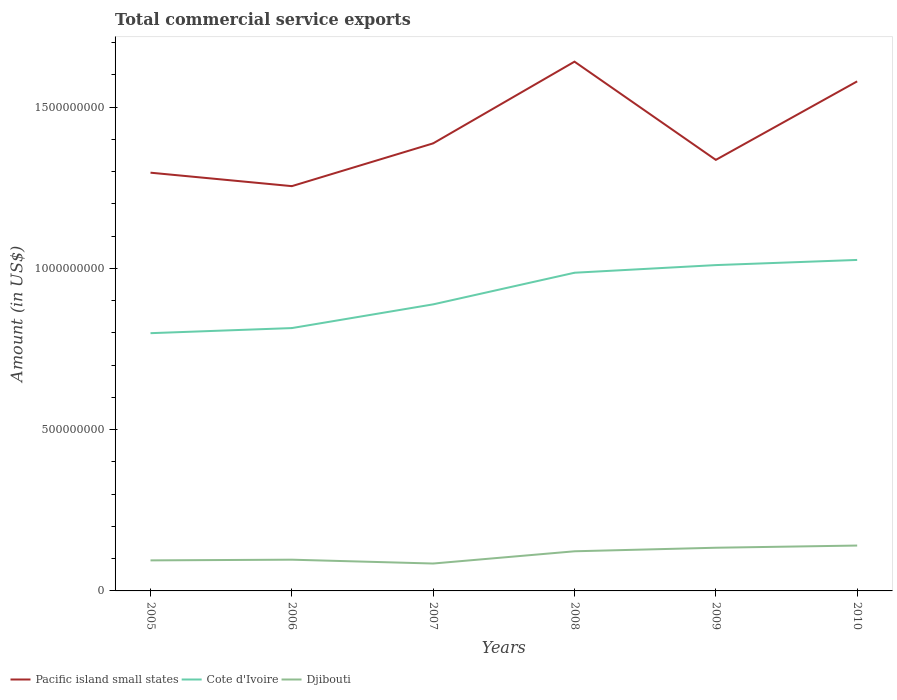How many different coloured lines are there?
Your answer should be compact. 3. Does the line corresponding to Cote d'Ivoire intersect with the line corresponding to Pacific island small states?
Make the answer very short. No. Across all years, what is the maximum total commercial service exports in Djibouti?
Provide a succinct answer. 8.50e+07. What is the total total commercial service exports in Djibouti in the graph?
Provide a short and direct response. -4.90e+07. What is the difference between the highest and the second highest total commercial service exports in Pacific island small states?
Provide a short and direct response. 3.86e+08. Is the total commercial service exports in Cote d'Ivoire strictly greater than the total commercial service exports in Pacific island small states over the years?
Ensure brevity in your answer.  Yes. How many years are there in the graph?
Offer a very short reply. 6. Are the values on the major ticks of Y-axis written in scientific E-notation?
Your answer should be very brief. No. Where does the legend appear in the graph?
Give a very brief answer. Bottom left. What is the title of the graph?
Ensure brevity in your answer.  Total commercial service exports. What is the label or title of the X-axis?
Keep it short and to the point. Years. What is the label or title of the Y-axis?
Your answer should be compact. Amount (in US$). What is the Amount (in US$) in Pacific island small states in 2005?
Offer a very short reply. 1.30e+09. What is the Amount (in US$) in Cote d'Ivoire in 2005?
Ensure brevity in your answer.  7.99e+08. What is the Amount (in US$) in Djibouti in 2005?
Keep it short and to the point. 9.47e+07. What is the Amount (in US$) of Pacific island small states in 2006?
Make the answer very short. 1.26e+09. What is the Amount (in US$) in Cote d'Ivoire in 2006?
Ensure brevity in your answer.  8.15e+08. What is the Amount (in US$) of Djibouti in 2006?
Ensure brevity in your answer.  9.68e+07. What is the Amount (in US$) in Pacific island small states in 2007?
Your response must be concise. 1.39e+09. What is the Amount (in US$) in Cote d'Ivoire in 2007?
Make the answer very short. 8.89e+08. What is the Amount (in US$) in Djibouti in 2007?
Offer a terse response. 8.50e+07. What is the Amount (in US$) in Pacific island small states in 2008?
Provide a succinct answer. 1.64e+09. What is the Amount (in US$) of Cote d'Ivoire in 2008?
Offer a terse response. 9.87e+08. What is the Amount (in US$) of Djibouti in 2008?
Your answer should be compact. 1.23e+08. What is the Amount (in US$) of Pacific island small states in 2009?
Your answer should be very brief. 1.34e+09. What is the Amount (in US$) in Cote d'Ivoire in 2009?
Provide a succinct answer. 1.01e+09. What is the Amount (in US$) of Djibouti in 2009?
Provide a short and direct response. 1.34e+08. What is the Amount (in US$) of Pacific island small states in 2010?
Offer a terse response. 1.58e+09. What is the Amount (in US$) in Cote d'Ivoire in 2010?
Ensure brevity in your answer.  1.03e+09. What is the Amount (in US$) of Djibouti in 2010?
Provide a succinct answer. 1.41e+08. Across all years, what is the maximum Amount (in US$) in Pacific island small states?
Give a very brief answer. 1.64e+09. Across all years, what is the maximum Amount (in US$) in Cote d'Ivoire?
Give a very brief answer. 1.03e+09. Across all years, what is the maximum Amount (in US$) of Djibouti?
Offer a terse response. 1.41e+08. Across all years, what is the minimum Amount (in US$) in Pacific island small states?
Provide a succinct answer. 1.26e+09. Across all years, what is the minimum Amount (in US$) of Cote d'Ivoire?
Your answer should be compact. 7.99e+08. Across all years, what is the minimum Amount (in US$) in Djibouti?
Give a very brief answer. 8.50e+07. What is the total Amount (in US$) in Pacific island small states in the graph?
Provide a succinct answer. 8.50e+09. What is the total Amount (in US$) of Cote d'Ivoire in the graph?
Your response must be concise. 5.53e+09. What is the total Amount (in US$) in Djibouti in the graph?
Keep it short and to the point. 6.74e+08. What is the difference between the Amount (in US$) of Pacific island small states in 2005 and that in 2006?
Ensure brevity in your answer.  4.17e+07. What is the difference between the Amount (in US$) of Cote d'Ivoire in 2005 and that in 2006?
Ensure brevity in your answer.  -1.58e+07. What is the difference between the Amount (in US$) of Djibouti in 2005 and that in 2006?
Your answer should be compact. -2.09e+06. What is the difference between the Amount (in US$) in Pacific island small states in 2005 and that in 2007?
Give a very brief answer. -9.10e+07. What is the difference between the Amount (in US$) of Cote d'Ivoire in 2005 and that in 2007?
Keep it short and to the point. -8.93e+07. What is the difference between the Amount (in US$) of Djibouti in 2005 and that in 2007?
Offer a very short reply. 9.78e+06. What is the difference between the Amount (in US$) in Pacific island small states in 2005 and that in 2008?
Your answer should be compact. -3.44e+08. What is the difference between the Amount (in US$) of Cote d'Ivoire in 2005 and that in 2008?
Provide a succinct answer. -1.87e+08. What is the difference between the Amount (in US$) of Djibouti in 2005 and that in 2008?
Provide a short and direct response. -2.82e+07. What is the difference between the Amount (in US$) in Pacific island small states in 2005 and that in 2009?
Your response must be concise. -3.97e+07. What is the difference between the Amount (in US$) in Cote d'Ivoire in 2005 and that in 2009?
Provide a short and direct response. -2.11e+08. What is the difference between the Amount (in US$) in Djibouti in 2005 and that in 2009?
Provide a short and direct response. -3.92e+07. What is the difference between the Amount (in US$) in Pacific island small states in 2005 and that in 2010?
Offer a terse response. -2.83e+08. What is the difference between the Amount (in US$) in Cote d'Ivoire in 2005 and that in 2010?
Offer a terse response. -2.27e+08. What is the difference between the Amount (in US$) in Djibouti in 2005 and that in 2010?
Keep it short and to the point. -4.59e+07. What is the difference between the Amount (in US$) in Pacific island small states in 2006 and that in 2007?
Offer a terse response. -1.33e+08. What is the difference between the Amount (in US$) in Cote d'Ivoire in 2006 and that in 2007?
Keep it short and to the point. -7.35e+07. What is the difference between the Amount (in US$) in Djibouti in 2006 and that in 2007?
Provide a succinct answer. 1.19e+07. What is the difference between the Amount (in US$) in Pacific island small states in 2006 and that in 2008?
Your response must be concise. -3.86e+08. What is the difference between the Amount (in US$) in Cote d'Ivoire in 2006 and that in 2008?
Provide a succinct answer. -1.72e+08. What is the difference between the Amount (in US$) of Djibouti in 2006 and that in 2008?
Your response must be concise. -2.61e+07. What is the difference between the Amount (in US$) in Pacific island small states in 2006 and that in 2009?
Your answer should be compact. -8.14e+07. What is the difference between the Amount (in US$) of Cote d'Ivoire in 2006 and that in 2009?
Make the answer very short. -1.95e+08. What is the difference between the Amount (in US$) of Djibouti in 2006 and that in 2009?
Your response must be concise. -3.71e+07. What is the difference between the Amount (in US$) of Pacific island small states in 2006 and that in 2010?
Provide a short and direct response. -3.25e+08. What is the difference between the Amount (in US$) in Cote d'Ivoire in 2006 and that in 2010?
Offer a very short reply. -2.11e+08. What is the difference between the Amount (in US$) in Djibouti in 2006 and that in 2010?
Offer a very short reply. -4.39e+07. What is the difference between the Amount (in US$) of Pacific island small states in 2007 and that in 2008?
Your response must be concise. -2.53e+08. What is the difference between the Amount (in US$) in Cote d'Ivoire in 2007 and that in 2008?
Provide a short and direct response. -9.81e+07. What is the difference between the Amount (in US$) in Djibouti in 2007 and that in 2008?
Give a very brief answer. -3.79e+07. What is the difference between the Amount (in US$) of Pacific island small states in 2007 and that in 2009?
Provide a short and direct response. 5.12e+07. What is the difference between the Amount (in US$) in Cote d'Ivoire in 2007 and that in 2009?
Offer a terse response. -1.22e+08. What is the difference between the Amount (in US$) in Djibouti in 2007 and that in 2009?
Give a very brief answer. -4.90e+07. What is the difference between the Amount (in US$) in Pacific island small states in 2007 and that in 2010?
Offer a very short reply. -1.92e+08. What is the difference between the Amount (in US$) in Cote d'Ivoire in 2007 and that in 2010?
Your answer should be compact. -1.38e+08. What is the difference between the Amount (in US$) of Djibouti in 2007 and that in 2010?
Offer a terse response. -5.57e+07. What is the difference between the Amount (in US$) in Pacific island small states in 2008 and that in 2009?
Keep it short and to the point. 3.05e+08. What is the difference between the Amount (in US$) in Cote d'Ivoire in 2008 and that in 2009?
Offer a terse response. -2.37e+07. What is the difference between the Amount (in US$) in Djibouti in 2008 and that in 2009?
Provide a short and direct response. -1.10e+07. What is the difference between the Amount (in US$) of Pacific island small states in 2008 and that in 2010?
Offer a very short reply. 6.11e+07. What is the difference between the Amount (in US$) in Cote d'Ivoire in 2008 and that in 2010?
Ensure brevity in your answer.  -3.97e+07. What is the difference between the Amount (in US$) of Djibouti in 2008 and that in 2010?
Offer a very short reply. -1.78e+07. What is the difference between the Amount (in US$) of Pacific island small states in 2009 and that in 2010?
Your answer should be very brief. -2.43e+08. What is the difference between the Amount (in US$) in Cote d'Ivoire in 2009 and that in 2010?
Offer a very short reply. -1.60e+07. What is the difference between the Amount (in US$) of Djibouti in 2009 and that in 2010?
Offer a terse response. -6.77e+06. What is the difference between the Amount (in US$) of Pacific island small states in 2005 and the Amount (in US$) of Cote d'Ivoire in 2006?
Provide a short and direct response. 4.82e+08. What is the difference between the Amount (in US$) of Pacific island small states in 2005 and the Amount (in US$) of Djibouti in 2006?
Provide a succinct answer. 1.20e+09. What is the difference between the Amount (in US$) of Cote d'Ivoire in 2005 and the Amount (in US$) of Djibouti in 2006?
Provide a short and direct response. 7.02e+08. What is the difference between the Amount (in US$) of Pacific island small states in 2005 and the Amount (in US$) of Cote d'Ivoire in 2007?
Ensure brevity in your answer.  4.08e+08. What is the difference between the Amount (in US$) of Pacific island small states in 2005 and the Amount (in US$) of Djibouti in 2007?
Your response must be concise. 1.21e+09. What is the difference between the Amount (in US$) in Cote d'Ivoire in 2005 and the Amount (in US$) in Djibouti in 2007?
Give a very brief answer. 7.14e+08. What is the difference between the Amount (in US$) in Pacific island small states in 2005 and the Amount (in US$) in Cote d'Ivoire in 2008?
Offer a terse response. 3.10e+08. What is the difference between the Amount (in US$) in Pacific island small states in 2005 and the Amount (in US$) in Djibouti in 2008?
Offer a terse response. 1.17e+09. What is the difference between the Amount (in US$) in Cote d'Ivoire in 2005 and the Amount (in US$) in Djibouti in 2008?
Make the answer very short. 6.76e+08. What is the difference between the Amount (in US$) of Pacific island small states in 2005 and the Amount (in US$) of Cote d'Ivoire in 2009?
Give a very brief answer. 2.87e+08. What is the difference between the Amount (in US$) in Pacific island small states in 2005 and the Amount (in US$) in Djibouti in 2009?
Provide a short and direct response. 1.16e+09. What is the difference between the Amount (in US$) in Cote d'Ivoire in 2005 and the Amount (in US$) in Djibouti in 2009?
Your response must be concise. 6.65e+08. What is the difference between the Amount (in US$) of Pacific island small states in 2005 and the Amount (in US$) of Cote d'Ivoire in 2010?
Provide a short and direct response. 2.71e+08. What is the difference between the Amount (in US$) in Pacific island small states in 2005 and the Amount (in US$) in Djibouti in 2010?
Provide a short and direct response. 1.16e+09. What is the difference between the Amount (in US$) in Cote d'Ivoire in 2005 and the Amount (in US$) in Djibouti in 2010?
Your response must be concise. 6.59e+08. What is the difference between the Amount (in US$) of Pacific island small states in 2006 and the Amount (in US$) of Cote d'Ivoire in 2007?
Give a very brief answer. 3.67e+08. What is the difference between the Amount (in US$) of Pacific island small states in 2006 and the Amount (in US$) of Djibouti in 2007?
Your answer should be very brief. 1.17e+09. What is the difference between the Amount (in US$) in Cote d'Ivoire in 2006 and the Amount (in US$) in Djibouti in 2007?
Give a very brief answer. 7.30e+08. What is the difference between the Amount (in US$) of Pacific island small states in 2006 and the Amount (in US$) of Cote d'Ivoire in 2008?
Ensure brevity in your answer.  2.69e+08. What is the difference between the Amount (in US$) of Pacific island small states in 2006 and the Amount (in US$) of Djibouti in 2008?
Provide a short and direct response. 1.13e+09. What is the difference between the Amount (in US$) of Cote d'Ivoire in 2006 and the Amount (in US$) of Djibouti in 2008?
Offer a very short reply. 6.92e+08. What is the difference between the Amount (in US$) in Pacific island small states in 2006 and the Amount (in US$) in Cote d'Ivoire in 2009?
Offer a terse response. 2.45e+08. What is the difference between the Amount (in US$) in Pacific island small states in 2006 and the Amount (in US$) in Djibouti in 2009?
Your answer should be very brief. 1.12e+09. What is the difference between the Amount (in US$) of Cote d'Ivoire in 2006 and the Amount (in US$) of Djibouti in 2009?
Make the answer very short. 6.81e+08. What is the difference between the Amount (in US$) in Pacific island small states in 2006 and the Amount (in US$) in Cote d'Ivoire in 2010?
Give a very brief answer. 2.29e+08. What is the difference between the Amount (in US$) of Pacific island small states in 2006 and the Amount (in US$) of Djibouti in 2010?
Keep it short and to the point. 1.11e+09. What is the difference between the Amount (in US$) in Cote d'Ivoire in 2006 and the Amount (in US$) in Djibouti in 2010?
Provide a short and direct response. 6.74e+08. What is the difference between the Amount (in US$) in Pacific island small states in 2007 and the Amount (in US$) in Cote d'Ivoire in 2008?
Your response must be concise. 4.01e+08. What is the difference between the Amount (in US$) in Pacific island small states in 2007 and the Amount (in US$) in Djibouti in 2008?
Give a very brief answer. 1.26e+09. What is the difference between the Amount (in US$) in Cote d'Ivoire in 2007 and the Amount (in US$) in Djibouti in 2008?
Offer a terse response. 7.66e+08. What is the difference between the Amount (in US$) of Pacific island small states in 2007 and the Amount (in US$) of Cote d'Ivoire in 2009?
Your response must be concise. 3.78e+08. What is the difference between the Amount (in US$) of Pacific island small states in 2007 and the Amount (in US$) of Djibouti in 2009?
Offer a terse response. 1.25e+09. What is the difference between the Amount (in US$) of Cote d'Ivoire in 2007 and the Amount (in US$) of Djibouti in 2009?
Offer a very short reply. 7.55e+08. What is the difference between the Amount (in US$) in Pacific island small states in 2007 and the Amount (in US$) in Cote d'Ivoire in 2010?
Ensure brevity in your answer.  3.61e+08. What is the difference between the Amount (in US$) of Pacific island small states in 2007 and the Amount (in US$) of Djibouti in 2010?
Offer a very short reply. 1.25e+09. What is the difference between the Amount (in US$) in Cote d'Ivoire in 2007 and the Amount (in US$) in Djibouti in 2010?
Your answer should be compact. 7.48e+08. What is the difference between the Amount (in US$) of Pacific island small states in 2008 and the Amount (in US$) of Cote d'Ivoire in 2009?
Provide a succinct answer. 6.31e+08. What is the difference between the Amount (in US$) of Pacific island small states in 2008 and the Amount (in US$) of Djibouti in 2009?
Make the answer very short. 1.51e+09. What is the difference between the Amount (in US$) in Cote d'Ivoire in 2008 and the Amount (in US$) in Djibouti in 2009?
Your answer should be very brief. 8.53e+08. What is the difference between the Amount (in US$) in Pacific island small states in 2008 and the Amount (in US$) in Cote d'Ivoire in 2010?
Your answer should be very brief. 6.15e+08. What is the difference between the Amount (in US$) of Pacific island small states in 2008 and the Amount (in US$) of Djibouti in 2010?
Provide a succinct answer. 1.50e+09. What is the difference between the Amount (in US$) in Cote d'Ivoire in 2008 and the Amount (in US$) in Djibouti in 2010?
Make the answer very short. 8.46e+08. What is the difference between the Amount (in US$) of Pacific island small states in 2009 and the Amount (in US$) of Cote d'Ivoire in 2010?
Provide a short and direct response. 3.10e+08. What is the difference between the Amount (in US$) in Pacific island small states in 2009 and the Amount (in US$) in Djibouti in 2010?
Offer a very short reply. 1.20e+09. What is the difference between the Amount (in US$) of Cote d'Ivoire in 2009 and the Amount (in US$) of Djibouti in 2010?
Give a very brief answer. 8.70e+08. What is the average Amount (in US$) in Pacific island small states per year?
Ensure brevity in your answer.  1.42e+09. What is the average Amount (in US$) of Cote d'Ivoire per year?
Offer a very short reply. 9.21e+08. What is the average Amount (in US$) of Djibouti per year?
Give a very brief answer. 1.12e+08. In the year 2005, what is the difference between the Amount (in US$) of Pacific island small states and Amount (in US$) of Cote d'Ivoire?
Provide a succinct answer. 4.98e+08. In the year 2005, what is the difference between the Amount (in US$) in Pacific island small states and Amount (in US$) in Djibouti?
Provide a short and direct response. 1.20e+09. In the year 2005, what is the difference between the Amount (in US$) in Cote d'Ivoire and Amount (in US$) in Djibouti?
Your answer should be compact. 7.05e+08. In the year 2006, what is the difference between the Amount (in US$) in Pacific island small states and Amount (in US$) in Cote d'Ivoire?
Your answer should be compact. 4.40e+08. In the year 2006, what is the difference between the Amount (in US$) in Pacific island small states and Amount (in US$) in Djibouti?
Provide a succinct answer. 1.16e+09. In the year 2006, what is the difference between the Amount (in US$) in Cote d'Ivoire and Amount (in US$) in Djibouti?
Offer a terse response. 7.18e+08. In the year 2007, what is the difference between the Amount (in US$) of Pacific island small states and Amount (in US$) of Cote d'Ivoire?
Your answer should be compact. 4.99e+08. In the year 2007, what is the difference between the Amount (in US$) in Pacific island small states and Amount (in US$) in Djibouti?
Your answer should be very brief. 1.30e+09. In the year 2007, what is the difference between the Amount (in US$) in Cote d'Ivoire and Amount (in US$) in Djibouti?
Your answer should be very brief. 8.04e+08. In the year 2008, what is the difference between the Amount (in US$) in Pacific island small states and Amount (in US$) in Cote d'Ivoire?
Offer a terse response. 6.55e+08. In the year 2008, what is the difference between the Amount (in US$) in Pacific island small states and Amount (in US$) in Djibouti?
Provide a short and direct response. 1.52e+09. In the year 2008, what is the difference between the Amount (in US$) in Cote d'Ivoire and Amount (in US$) in Djibouti?
Ensure brevity in your answer.  8.64e+08. In the year 2009, what is the difference between the Amount (in US$) of Pacific island small states and Amount (in US$) of Cote d'Ivoire?
Make the answer very short. 3.26e+08. In the year 2009, what is the difference between the Amount (in US$) in Pacific island small states and Amount (in US$) in Djibouti?
Provide a succinct answer. 1.20e+09. In the year 2009, what is the difference between the Amount (in US$) in Cote d'Ivoire and Amount (in US$) in Djibouti?
Keep it short and to the point. 8.76e+08. In the year 2010, what is the difference between the Amount (in US$) of Pacific island small states and Amount (in US$) of Cote d'Ivoire?
Keep it short and to the point. 5.54e+08. In the year 2010, what is the difference between the Amount (in US$) in Pacific island small states and Amount (in US$) in Djibouti?
Your response must be concise. 1.44e+09. In the year 2010, what is the difference between the Amount (in US$) of Cote d'Ivoire and Amount (in US$) of Djibouti?
Make the answer very short. 8.86e+08. What is the ratio of the Amount (in US$) of Pacific island small states in 2005 to that in 2006?
Your response must be concise. 1.03. What is the ratio of the Amount (in US$) in Cote d'Ivoire in 2005 to that in 2006?
Your answer should be very brief. 0.98. What is the ratio of the Amount (in US$) in Djibouti in 2005 to that in 2006?
Your response must be concise. 0.98. What is the ratio of the Amount (in US$) in Pacific island small states in 2005 to that in 2007?
Your answer should be very brief. 0.93. What is the ratio of the Amount (in US$) in Cote d'Ivoire in 2005 to that in 2007?
Offer a very short reply. 0.9. What is the ratio of the Amount (in US$) of Djibouti in 2005 to that in 2007?
Ensure brevity in your answer.  1.12. What is the ratio of the Amount (in US$) of Pacific island small states in 2005 to that in 2008?
Ensure brevity in your answer.  0.79. What is the ratio of the Amount (in US$) of Cote d'Ivoire in 2005 to that in 2008?
Your answer should be very brief. 0.81. What is the ratio of the Amount (in US$) of Djibouti in 2005 to that in 2008?
Provide a short and direct response. 0.77. What is the ratio of the Amount (in US$) in Pacific island small states in 2005 to that in 2009?
Keep it short and to the point. 0.97. What is the ratio of the Amount (in US$) in Cote d'Ivoire in 2005 to that in 2009?
Give a very brief answer. 0.79. What is the ratio of the Amount (in US$) of Djibouti in 2005 to that in 2009?
Your answer should be compact. 0.71. What is the ratio of the Amount (in US$) in Pacific island small states in 2005 to that in 2010?
Ensure brevity in your answer.  0.82. What is the ratio of the Amount (in US$) in Cote d'Ivoire in 2005 to that in 2010?
Your response must be concise. 0.78. What is the ratio of the Amount (in US$) of Djibouti in 2005 to that in 2010?
Your response must be concise. 0.67. What is the ratio of the Amount (in US$) in Pacific island small states in 2006 to that in 2007?
Offer a very short reply. 0.9. What is the ratio of the Amount (in US$) in Cote d'Ivoire in 2006 to that in 2007?
Your answer should be very brief. 0.92. What is the ratio of the Amount (in US$) of Djibouti in 2006 to that in 2007?
Your response must be concise. 1.14. What is the ratio of the Amount (in US$) in Pacific island small states in 2006 to that in 2008?
Offer a very short reply. 0.76. What is the ratio of the Amount (in US$) in Cote d'Ivoire in 2006 to that in 2008?
Your answer should be compact. 0.83. What is the ratio of the Amount (in US$) in Djibouti in 2006 to that in 2008?
Your answer should be compact. 0.79. What is the ratio of the Amount (in US$) of Pacific island small states in 2006 to that in 2009?
Your response must be concise. 0.94. What is the ratio of the Amount (in US$) of Cote d'Ivoire in 2006 to that in 2009?
Offer a very short reply. 0.81. What is the ratio of the Amount (in US$) of Djibouti in 2006 to that in 2009?
Your answer should be compact. 0.72. What is the ratio of the Amount (in US$) in Pacific island small states in 2006 to that in 2010?
Your answer should be compact. 0.79. What is the ratio of the Amount (in US$) of Cote d'Ivoire in 2006 to that in 2010?
Give a very brief answer. 0.79. What is the ratio of the Amount (in US$) of Djibouti in 2006 to that in 2010?
Offer a terse response. 0.69. What is the ratio of the Amount (in US$) of Pacific island small states in 2007 to that in 2008?
Offer a very short reply. 0.85. What is the ratio of the Amount (in US$) in Cote d'Ivoire in 2007 to that in 2008?
Your response must be concise. 0.9. What is the ratio of the Amount (in US$) in Djibouti in 2007 to that in 2008?
Offer a very short reply. 0.69. What is the ratio of the Amount (in US$) in Pacific island small states in 2007 to that in 2009?
Make the answer very short. 1.04. What is the ratio of the Amount (in US$) of Cote d'Ivoire in 2007 to that in 2009?
Your answer should be very brief. 0.88. What is the ratio of the Amount (in US$) of Djibouti in 2007 to that in 2009?
Keep it short and to the point. 0.63. What is the ratio of the Amount (in US$) of Pacific island small states in 2007 to that in 2010?
Provide a short and direct response. 0.88. What is the ratio of the Amount (in US$) in Cote d'Ivoire in 2007 to that in 2010?
Keep it short and to the point. 0.87. What is the ratio of the Amount (in US$) of Djibouti in 2007 to that in 2010?
Your response must be concise. 0.6. What is the ratio of the Amount (in US$) in Pacific island small states in 2008 to that in 2009?
Your answer should be compact. 1.23. What is the ratio of the Amount (in US$) of Cote d'Ivoire in 2008 to that in 2009?
Make the answer very short. 0.98. What is the ratio of the Amount (in US$) of Djibouti in 2008 to that in 2009?
Give a very brief answer. 0.92. What is the ratio of the Amount (in US$) in Pacific island small states in 2008 to that in 2010?
Give a very brief answer. 1.04. What is the ratio of the Amount (in US$) of Cote d'Ivoire in 2008 to that in 2010?
Provide a short and direct response. 0.96. What is the ratio of the Amount (in US$) in Djibouti in 2008 to that in 2010?
Offer a very short reply. 0.87. What is the ratio of the Amount (in US$) in Pacific island small states in 2009 to that in 2010?
Your answer should be very brief. 0.85. What is the ratio of the Amount (in US$) of Cote d'Ivoire in 2009 to that in 2010?
Make the answer very short. 0.98. What is the ratio of the Amount (in US$) in Djibouti in 2009 to that in 2010?
Give a very brief answer. 0.95. What is the difference between the highest and the second highest Amount (in US$) in Pacific island small states?
Give a very brief answer. 6.11e+07. What is the difference between the highest and the second highest Amount (in US$) of Cote d'Ivoire?
Keep it short and to the point. 1.60e+07. What is the difference between the highest and the second highest Amount (in US$) in Djibouti?
Make the answer very short. 6.77e+06. What is the difference between the highest and the lowest Amount (in US$) of Pacific island small states?
Keep it short and to the point. 3.86e+08. What is the difference between the highest and the lowest Amount (in US$) in Cote d'Ivoire?
Provide a short and direct response. 2.27e+08. What is the difference between the highest and the lowest Amount (in US$) of Djibouti?
Make the answer very short. 5.57e+07. 